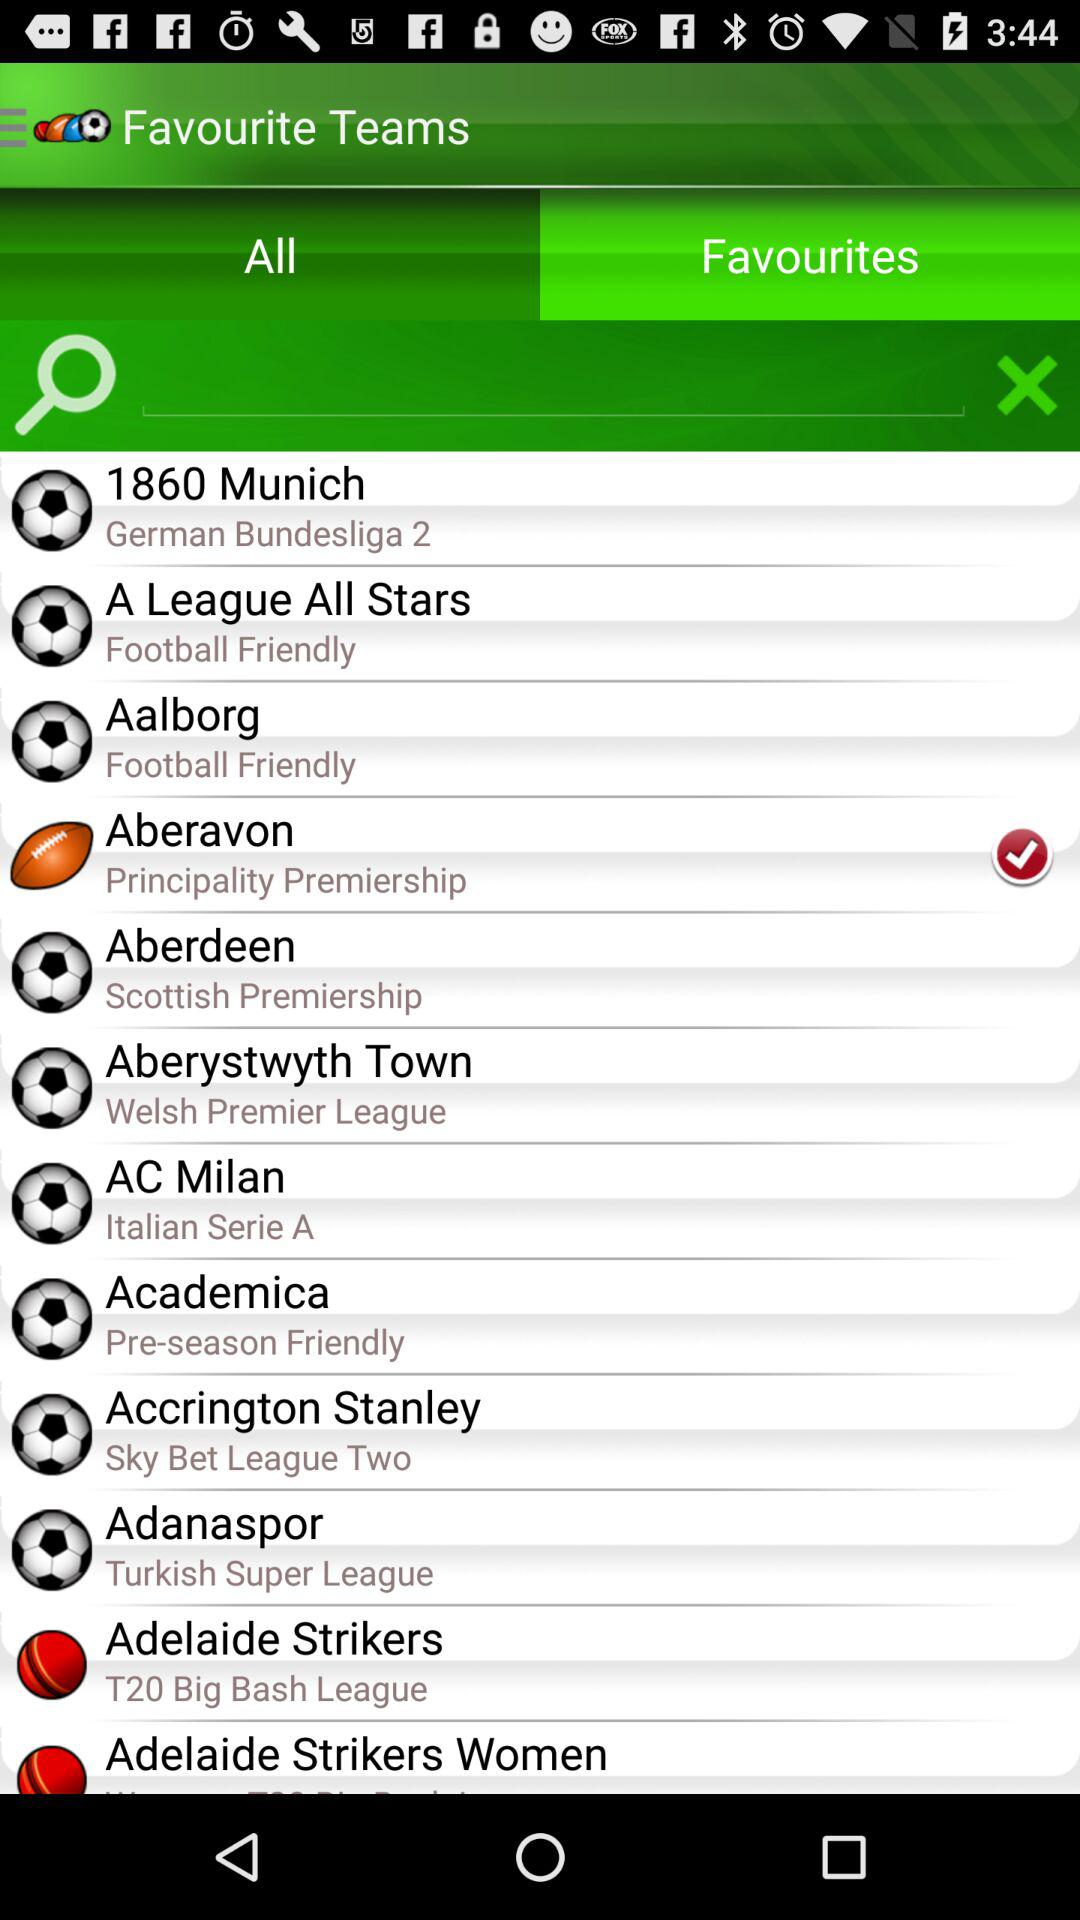Which is the selected tab? The selected tab is "Favourites". 